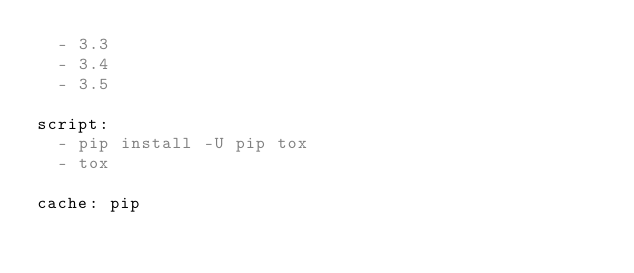Convert code to text. <code><loc_0><loc_0><loc_500><loc_500><_YAML_>  - 3.3
  - 3.4
  - 3.5

script:
  - pip install -U pip tox
  - tox

cache: pip
</code> 